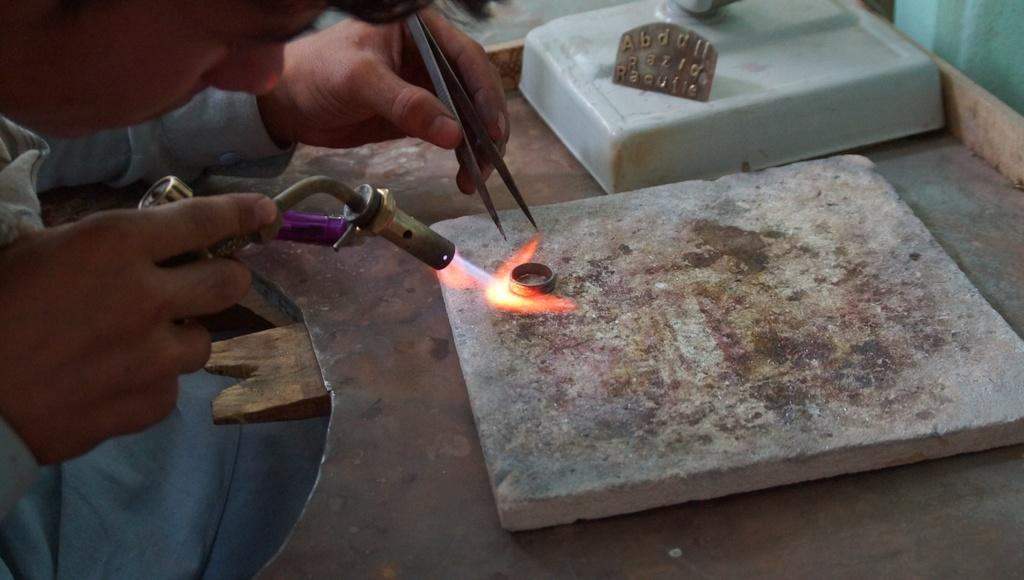What is the main subject of the image? There is a person in the image. What is the person holding in their hands? The person is holding tools in their hands. Can you describe any other objects in the image? There is a stone and a flame in the image, along with other objects. How many people are in the crowd in the image? There is no crowd present in the image; it features a person holding tools and other objects. What type of thumb can be seen interacting with the tools in the image? There is no thumb visible in the image; only the person's hands holding the tools are present. 